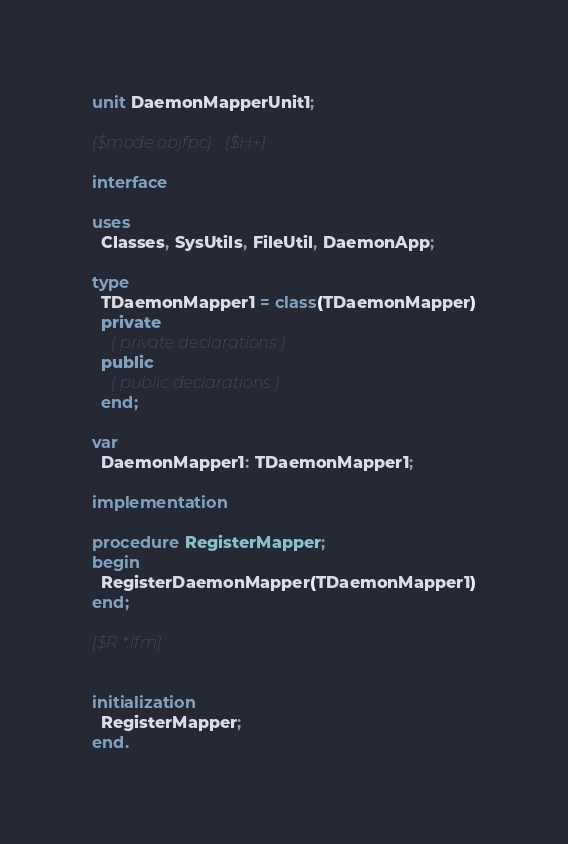Convert code to text. <code><loc_0><loc_0><loc_500><loc_500><_Pascal_>unit DaemonMapperUnit1;

{$mode objfpc}{$H+}

interface

uses
  Classes, SysUtils, FileUtil, DaemonApp;

type
  TDaemonMapper1 = class(TDaemonMapper)
  private
    { private declarations }
  public
    { public declarations }
  end;

var
  DaemonMapper1: TDaemonMapper1;

implementation

procedure RegisterMapper;
begin
  RegisterDaemonMapper(TDaemonMapper1)
end;

{$R *.lfm}


initialization
  RegisterMapper;
end.

</code> 